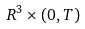Convert formula to latex. <formula><loc_0><loc_0><loc_500><loc_500>R ^ { 3 } \times ( 0 , T )</formula> 